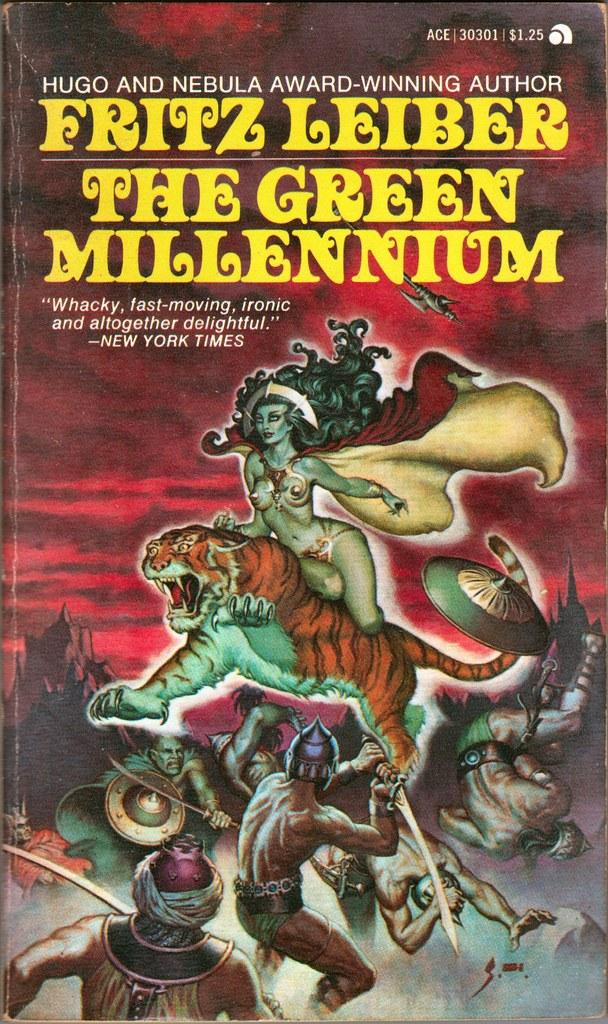<image>
Create a compact narrative representing the image presented. Book with a tiger and warrior on the cover named "The Green Millennium". 